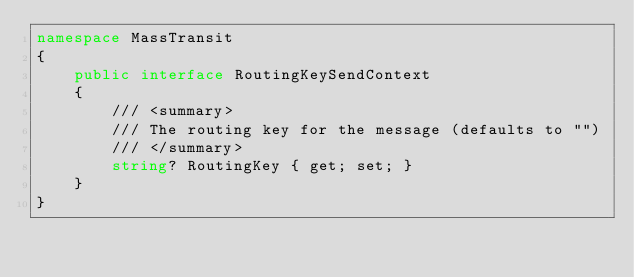Convert code to text. <code><loc_0><loc_0><loc_500><loc_500><_C#_>namespace MassTransit
{
    public interface RoutingKeySendContext
    {
        /// <summary>
        /// The routing key for the message (defaults to "")
        /// </summary>
        string? RoutingKey { get; set; }
    }
}
</code> 